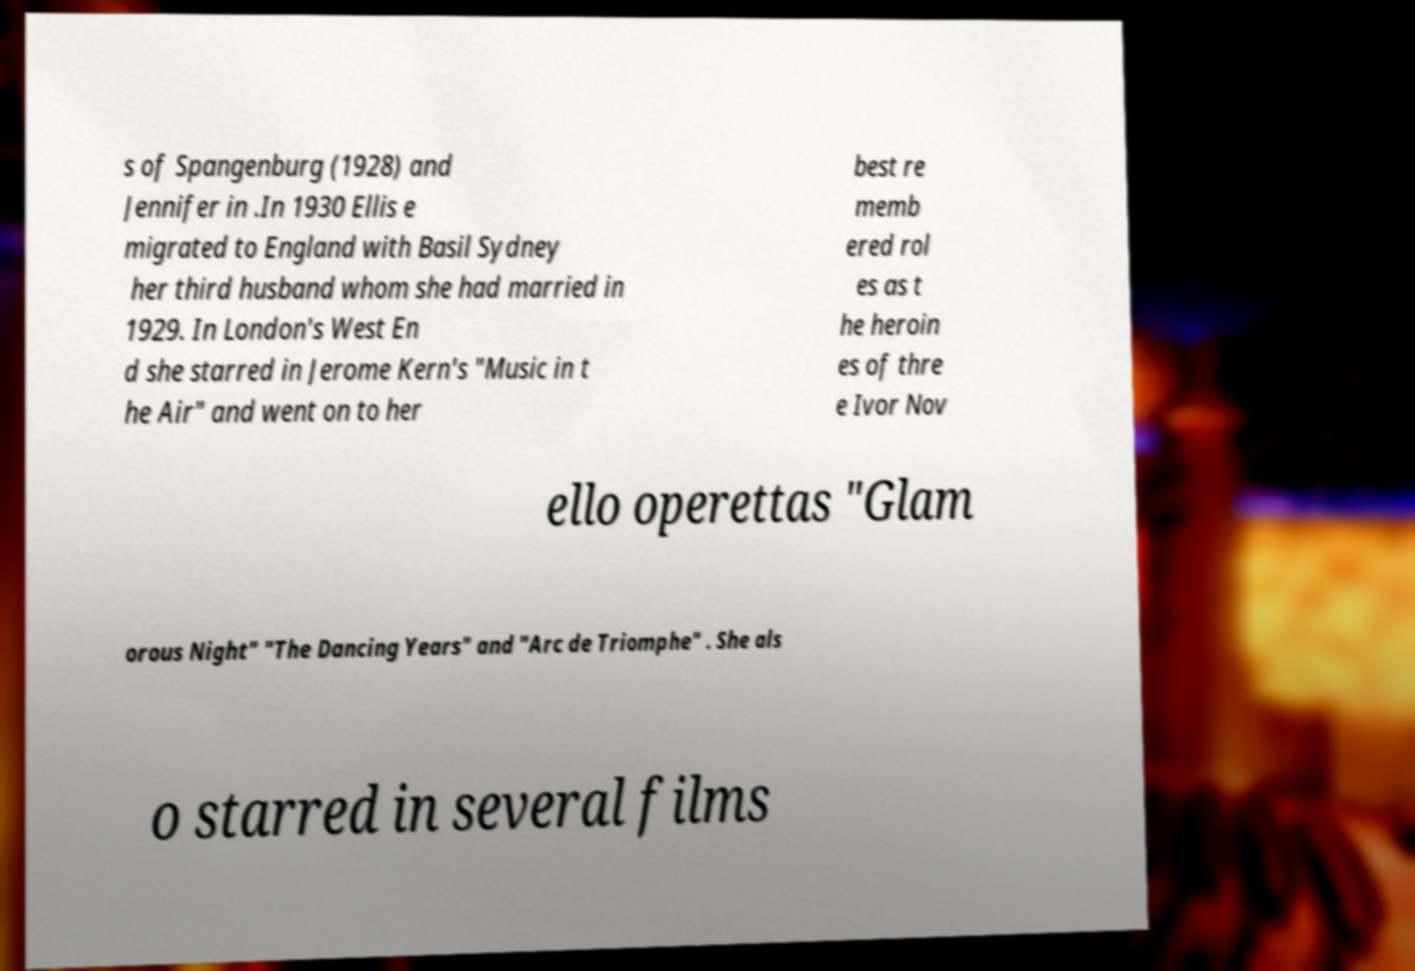Can you accurately transcribe the text from the provided image for me? s of Spangenburg (1928) and Jennifer in .In 1930 Ellis e migrated to England with Basil Sydney her third husband whom she had married in 1929. In London's West En d she starred in Jerome Kern's "Music in t he Air" and went on to her best re memb ered rol es as t he heroin es of thre e Ivor Nov ello operettas "Glam orous Night" "The Dancing Years" and "Arc de Triomphe" . She als o starred in several films 